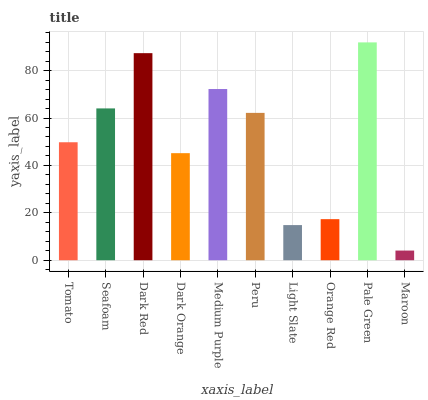Is Maroon the minimum?
Answer yes or no. Yes. Is Pale Green the maximum?
Answer yes or no. Yes. Is Seafoam the minimum?
Answer yes or no. No. Is Seafoam the maximum?
Answer yes or no. No. Is Seafoam greater than Tomato?
Answer yes or no. Yes. Is Tomato less than Seafoam?
Answer yes or no. Yes. Is Tomato greater than Seafoam?
Answer yes or no. No. Is Seafoam less than Tomato?
Answer yes or no. No. Is Peru the high median?
Answer yes or no. Yes. Is Tomato the low median?
Answer yes or no. Yes. Is Seafoam the high median?
Answer yes or no. No. Is Light Slate the low median?
Answer yes or no. No. 